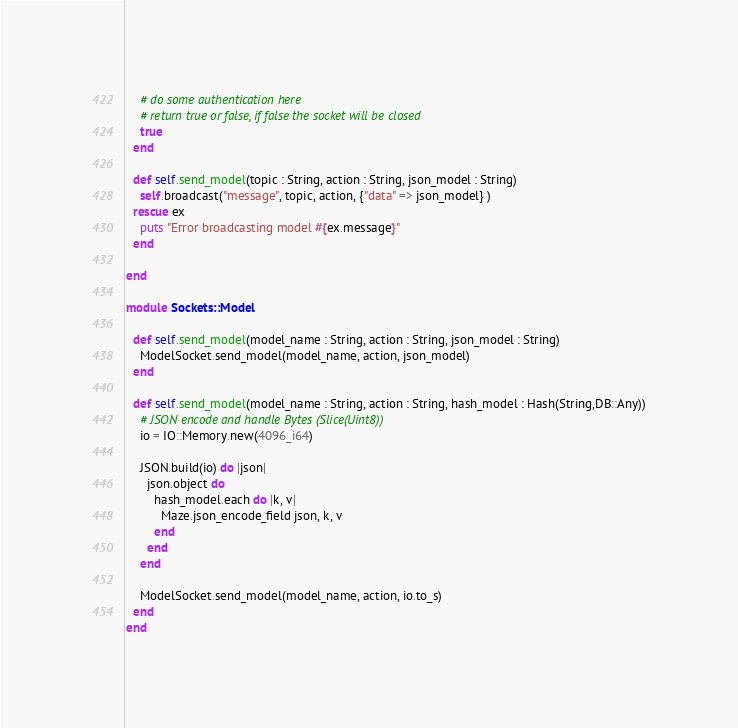Convert code to text. <code><loc_0><loc_0><loc_500><loc_500><_Crystal_>    # do some authentication here
    # return true or false, if false the socket will be closed
    true
  end

  def self.send_model(topic : String, action : String, json_model : String)
    self.broadcast("message", topic, action, {"data" => json_model} )
  rescue ex
    puts "Error broadcasting model #{ex.message}"
  end

end

module Sockets::Model

  def self.send_model(model_name : String, action : String, json_model : String)
    ModelSocket.send_model(model_name, action, json_model)
  end

  def self.send_model(model_name : String, action : String, hash_model : Hash(String,DB::Any))
    # JSON encode and handle Bytes (Slice(Uint8))
    io = IO::Memory.new(4096_i64)

    JSON.build(io) do |json|
      json.object do
        hash_model.each do |k, v|
          Maze.json_encode_field json, k, v
        end
      end
    end

    ModelSocket.send_model(model_name, action, io.to_s)
  end
end
</code> 